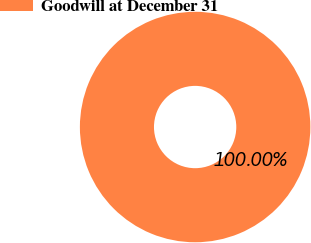Convert chart to OTSL. <chart><loc_0><loc_0><loc_500><loc_500><pie_chart><fcel>Goodwill at December 31<nl><fcel>100.0%<nl></chart> 